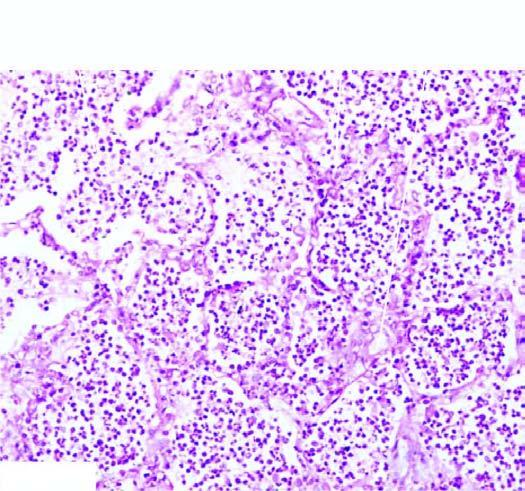what are filled with cellular exudates composed of neutrophils admixed with some red cells?
Answer the question using a single word or phrase. The alveoli 